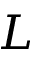Convert formula to latex. <formula><loc_0><loc_0><loc_500><loc_500>L</formula> 